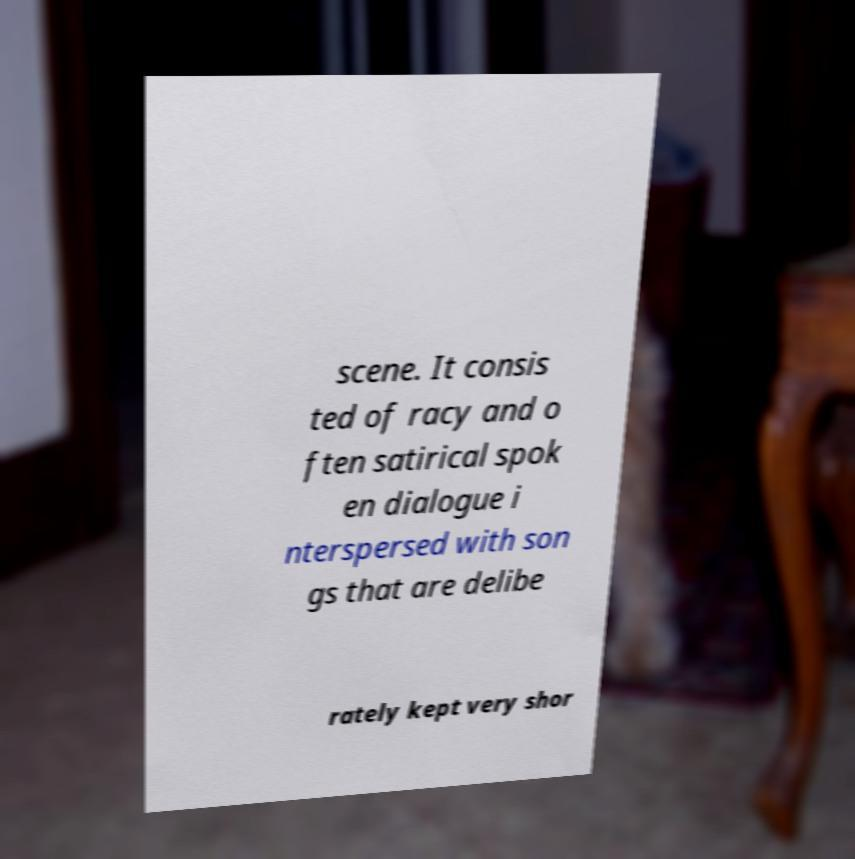There's text embedded in this image that I need extracted. Can you transcribe it verbatim? scene. It consis ted of racy and o ften satirical spok en dialogue i nterspersed with son gs that are delibe rately kept very shor 